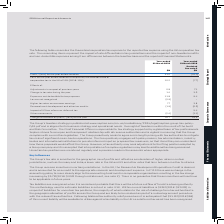According to Sophos Group's financial document, What do the reconciling items in the table represent? the impact of rate differentials in tax jurisdictions and the impact of non-taxable benefits and non-deductible expenses arising from differences between the local tax base and the reported Financial Statements.. The document states: "poration tax rate. The reconciling items represent the impact of rate differentials in tax jurisdictions and the impact of non-taxable benefits and no..." Also, What is the Chief Financial Officer responsible for? responsible for tax strategy supported by a global team of tax professionals. Sophos strives for an open and transparent relationship with all revenue authorities and is vigilant in ensuring that the Group complies with current tax legislation.. The document states: "and Risk Committee. The Chief Financial Officer is responsible for tax strategy supported by a global team of tax professionals. Sophos strives for an..." Also, In which years was the Charge for taxation on profit for the year recorded? The document shows two values: 2019 and 2018. From the document: "Year-ended 31 March 2019 Year-ended 31 March 2018 Restated See note 2 $M..." Additionally, In which year was the Charge for taxation on profit  for the year larger? According to the financial document, 2019. The relevant text states: "Year-ended 31 March 2019..." Also, can you calculate: What was the change in the Charge for taxation on profit  for the year in 2019 from 2018? Based on the calculation: 26.7-19.9, the result is 6.8 (in millions). This is based on the information: "for taxation on profit / (loss) for the year 26.7 19.9 arge for taxation on profit / (loss) for the year 26.7 19.9..." The key data points involved are: 19.9, 26.7. Also, can you calculate: What was the percentage change in the Charge for taxation on profit for the year in 2019 from 2018? To answer this question, I need to perform calculations using the financial data. The calculation is: (26.7-19.9)/19.9, which equals 34.17 (percentage). This is based on the information: "for taxation on profit / (loss) for the year 26.7 19.9 arge for taxation on profit / (loss) for the year 26.7 19.9..." The key data points involved are: 19.9, 26.7. 